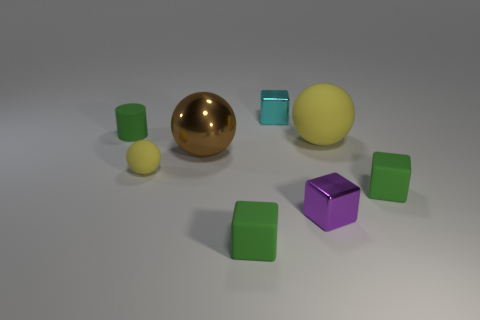What is the material of the purple object that is the same shape as the small cyan metallic object?
Provide a succinct answer. Metal. Is there a tiny yellow ball left of the yellow ball that is in front of the big thing left of the tiny cyan metallic object?
Offer a terse response. No. Do the purple block and the cyan shiny object have the same size?
Your answer should be very brief. Yes. There is a small metal thing that is behind the yellow matte object that is in front of the matte ball on the right side of the tiny yellow object; what color is it?
Make the answer very short. Cyan. How many blocks have the same color as the cylinder?
Offer a terse response. 2. How many big things are either green rubber blocks or yellow matte spheres?
Your answer should be very brief. 1. Is there a yellow rubber thing that has the same shape as the large brown thing?
Provide a succinct answer. Yes. Does the brown thing have the same shape as the purple metallic object?
Provide a succinct answer. No. What is the color of the tiny matte cube that is in front of the small metallic cube that is in front of the cylinder?
Provide a short and direct response. Green. The sphere that is the same size as the purple thing is what color?
Keep it short and to the point. Yellow. 